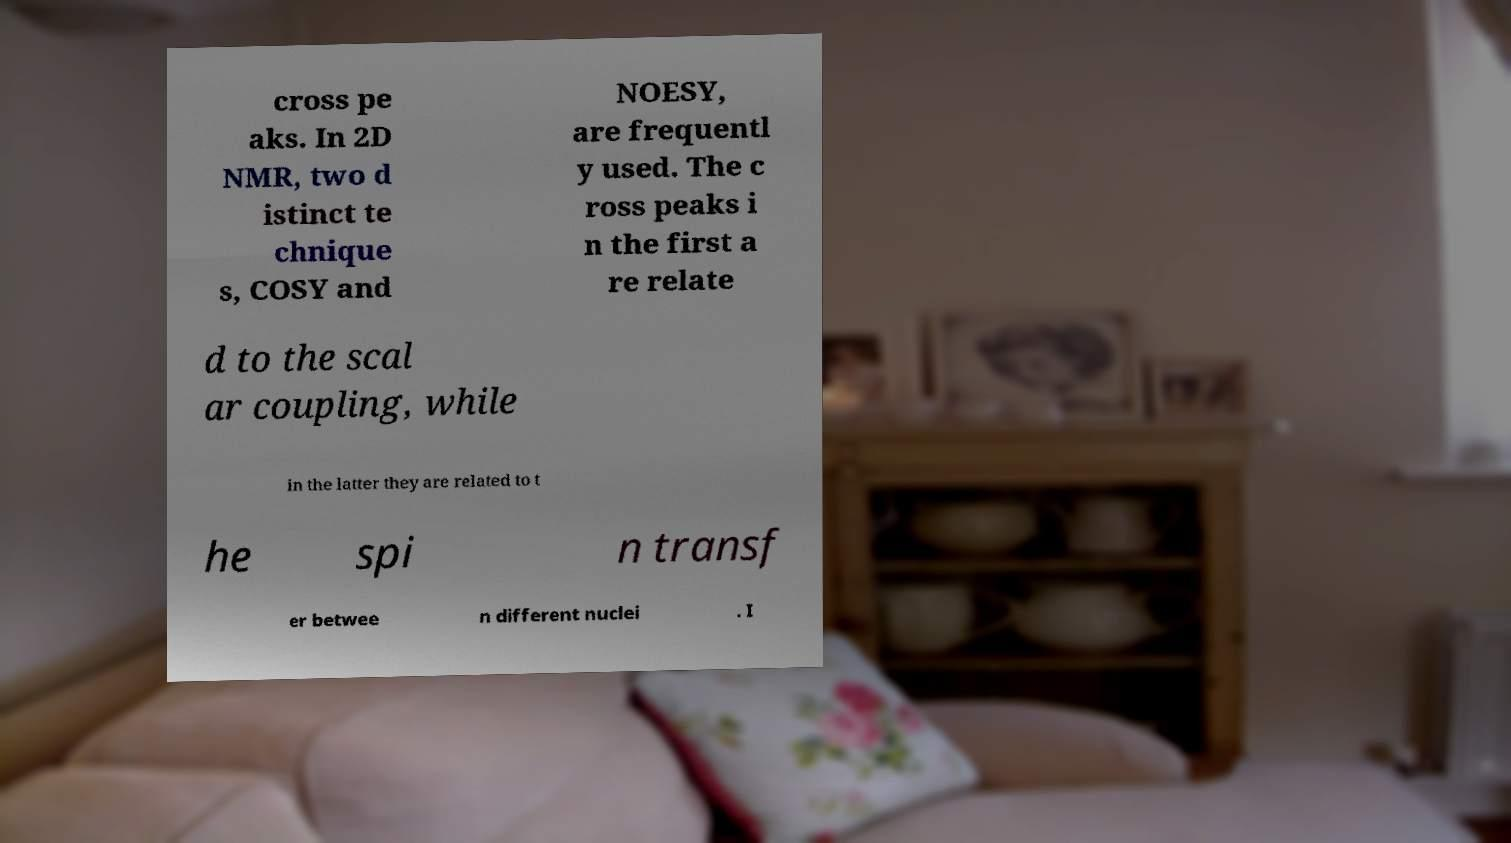Can you read and provide the text displayed in the image?This photo seems to have some interesting text. Can you extract and type it out for me? cross pe aks. In 2D NMR, two d istinct te chnique s, COSY and NOESY, are frequentl y used. The c ross peaks i n the first a re relate d to the scal ar coupling, while in the latter they are related to t he spi n transf er betwee n different nuclei . I 